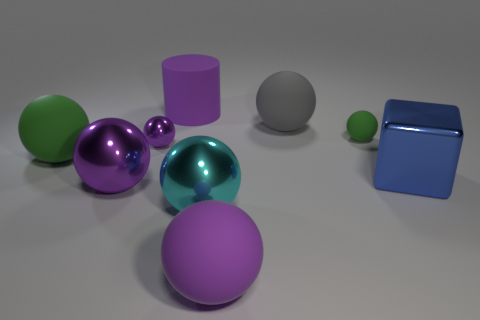Subtract all green blocks. How many purple spheres are left? 3 Subtract 4 balls. How many balls are left? 3 Subtract all big green rubber spheres. How many spheres are left? 6 Subtract all green balls. How many balls are left? 5 Subtract all brown spheres. Subtract all yellow cubes. How many spheres are left? 7 Subtract all cubes. How many objects are left? 8 Subtract all tiny purple metal spheres. Subtract all big cylinders. How many objects are left? 7 Add 5 big green rubber objects. How many big green rubber objects are left? 6 Add 7 purple rubber spheres. How many purple rubber spheres exist? 8 Subtract 0 blue balls. How many objects are left? 9 